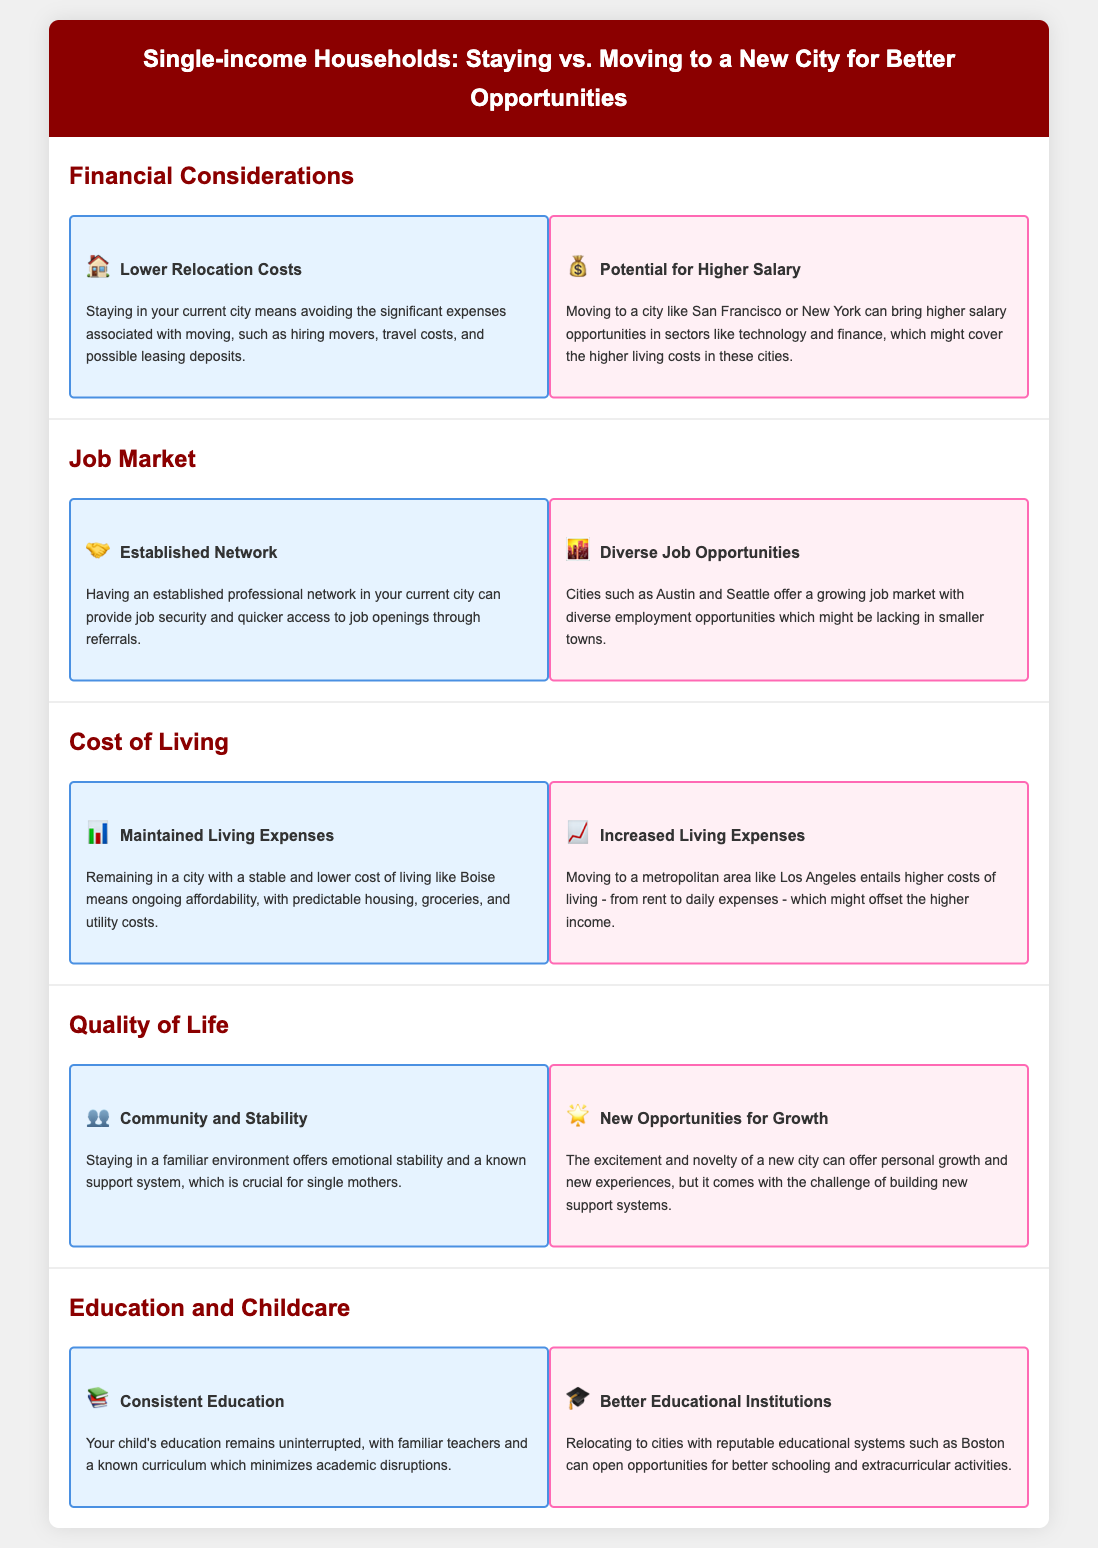What are the potential higher salary opportunities? Moving to a city like San Francisco or New York can bring higher salary opportunities in sectors like technology and finance.
Answer: Technology and finance What is a financial benefit of staying in your current city? Staying in your current city means avoiding the significant expenses associated with moving.
Answer: Lower relocation costs What does having an established professional network offer? Having an established professional network can provide job security and quicker access to job openings.
Answer: Job security What do cities like Austin and Seattle offer? Cities such as Austin and Seattle offer a growing job market with diverse employment opportunities.
Answer: Diverse job opportunities What stability is mentioned for single mothers staying in their environment? Staying in a familiar environment offers emotional stability and a known support system.
Answer: Emotional stability What is a concern with moving to a metropolitan area? Moving to a metropolitan area entails higher costs of living which might offset the higher income.
Answer: Increased living expenses What educational benefit is cited for staying? Your child's education remains uninterrupted with familiar teachers and a known curriculum.
Answer: Consistent education What opportunity may better educational institutions provide when moving? Relocating to cities with reputable educational systems can open opportunities for better schooling and extracurricular activities.
Answer: Better schooling 